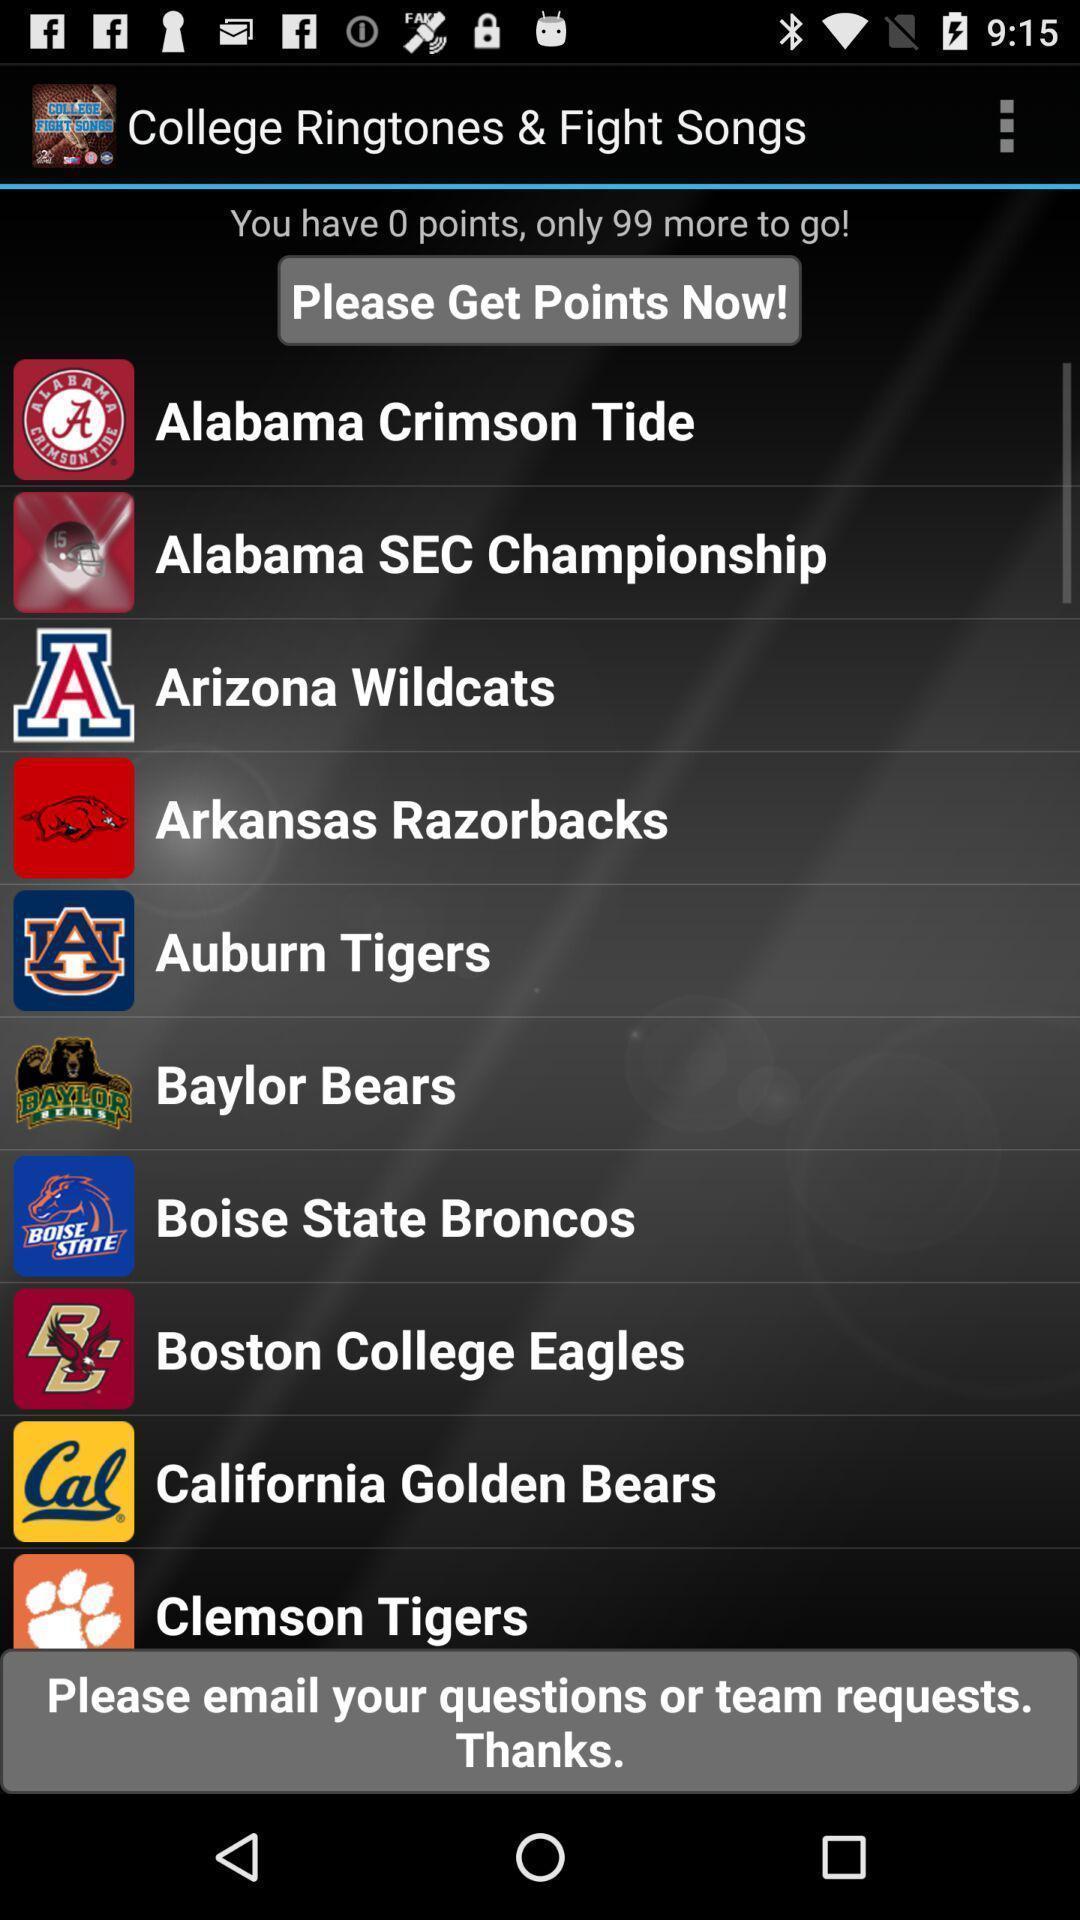Provide a detailed account of this screenshot. Screen displaying list of football and basketball teams. 